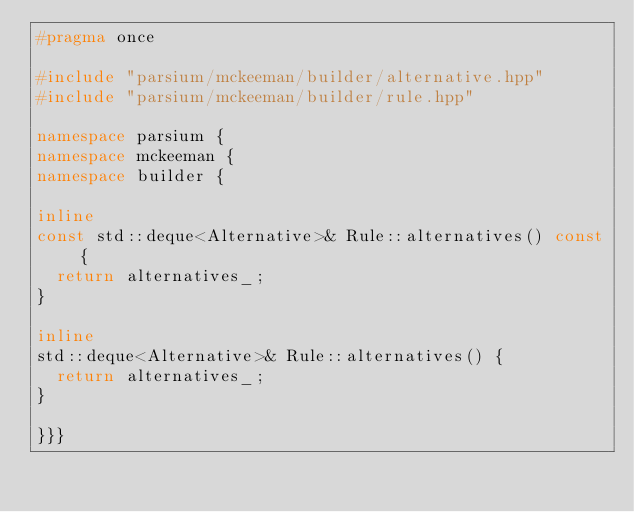<code> <loc_0><loc_0><loc_500><loc_500><_C++_>#pragma once

#include "parsium/mckeeman/builder/alternative.hpp"
#include "parsium/mckeeman/builder/rule.hpp"

namespace parsium {
namespace mckeeman {
namespace builder {

inline
const std::deque<Alternative>& Rule::alternatives() const {
	return alternatives_;
}

inline
std::deque<Alternative>& Rule::alternatives() {
	return alternatives_;
}

}}}
</code> 